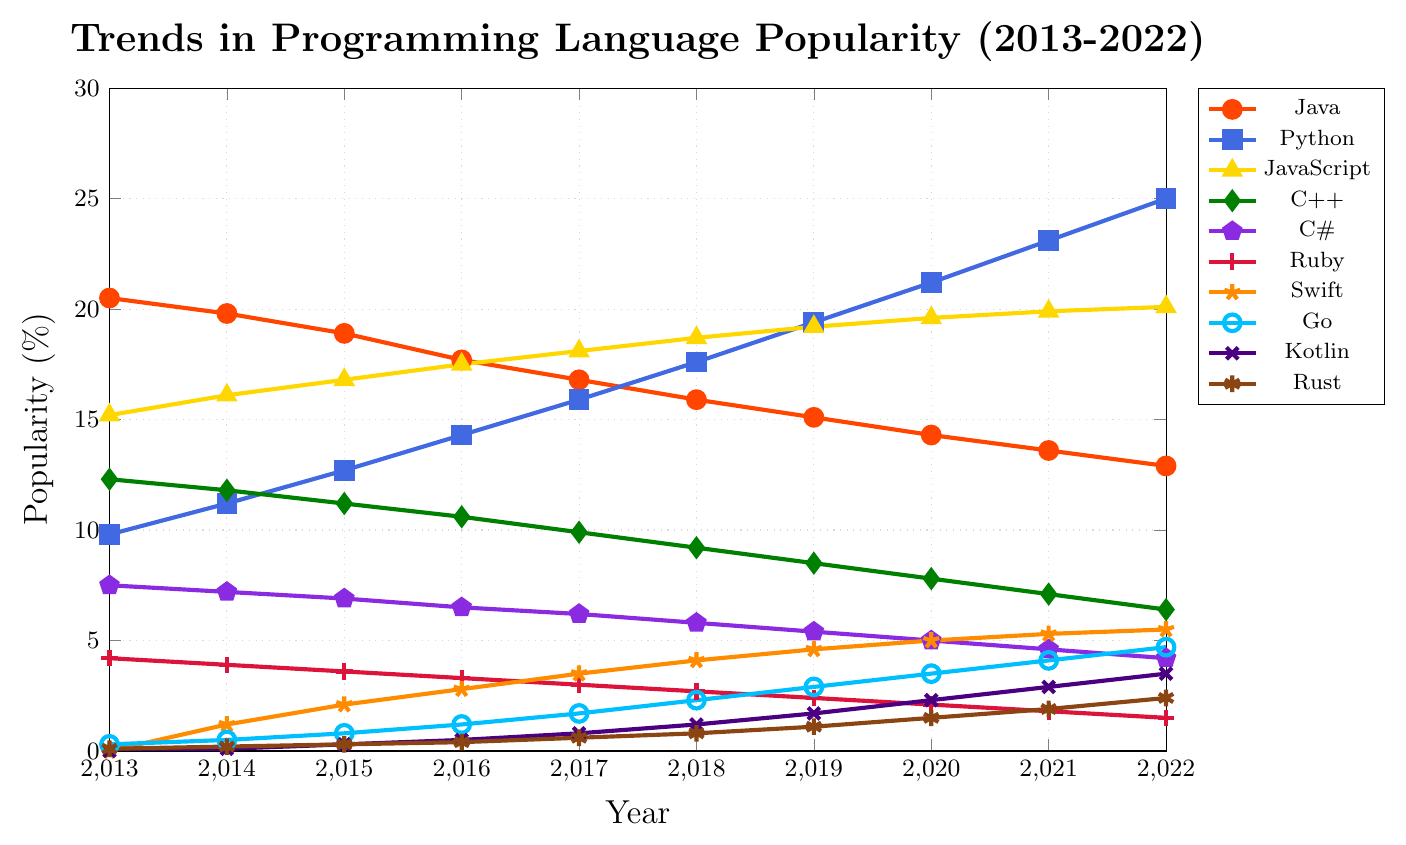Which programming language showed the most significant increase in popularity over the decade? Start by identifying the most recent values and comparing them to the values from 2013. Python increased from 9.8% in 2013 to 25.0% in 2022, showing the highest increase of 15.2%.
Answer: Python Which programming language's popularity was higher in 2022 compared to its popularity in 2016? For each language, compare the 2016 and 2022 data points. Python (14.3% to 25.0%), JavaScript (17.5% to 20.1%), Swift (2.8% to 5.5%), Go (1.2% to 4.7%), Kotlin (0.5% to 3.5%), and Rust (0.4% to 2.4%) had higher popularity in 2022.
Answer: Python, JavaScript, Swift, Go, Kotlin, Rust Between Java and JavaScript, which language has maintained a higher popularity throughout the decade? Compare the values for Java and JavaScript from 2013 to 2022. JavaScript had consistently higher popularity than Java in all these years.
Answer: JavaScript Which language had the highest popularity in 2017, and what was its value? Look at the 2017 data points for all languages and identify the highest value. JavaScript was the highest in 2017 with 18.1%.
Answer: JavaScript, 18.1% What is the average popularity of C++ from 2013 to 2022? Add the values of C++ for each year and divide by the number of years (10). (12.3 + 11.8 + 11.2 + 10.6 + 9.9 + 9.2 + 8.5 + 7.8 + 7.1 + 6.4) / 10 = 9.48.
Answer: 9.48% How does the popularity of Ruby in 2016 compare to that in 2022? Look at Ruby's popularity values for 2016 (3.3%) and 2022 (1.5%). Ruby's popularity decreased by 1.8% (3.3% - 1.5%) over this period.
Answer: Decreased by 1.8% Which language had the sharpest rise in popularity between any two consecutive years? Compare the year-over-year differences for all languages. Python had a significant rise between 2017 and 2018 (17.6% to 19.4%), a 1.8% increase being the largest jump noted.
Answer: Python Which languages were introduced after 2013, and what were their popularity percentages in 2022? Check the initial appearance year of each language. Swift (5.5%), Go (4.7%), Kotlin (3.5%), and Rust (2.4%) appeared after 2013. Also, note their 2022 values.
Answer: Swift 5.5%, Go 4.7%, Kotlin 3.5%, Rust 2.4% Between 2020 and 2022, which language saw the most consistent increase in its popularity? Compare the yearly differences between 2020 and 2022 for all languages. Python increased from 21.2% to 23.1% to 25.0%, showing a consistent upward trend.
Answer: Python In what year did Go surpass the 3% popularity mark for the first time? Review the yearly values for Go. Go surpassed 3% for the first time in 2020 (3.5%).
Answer: 2020 